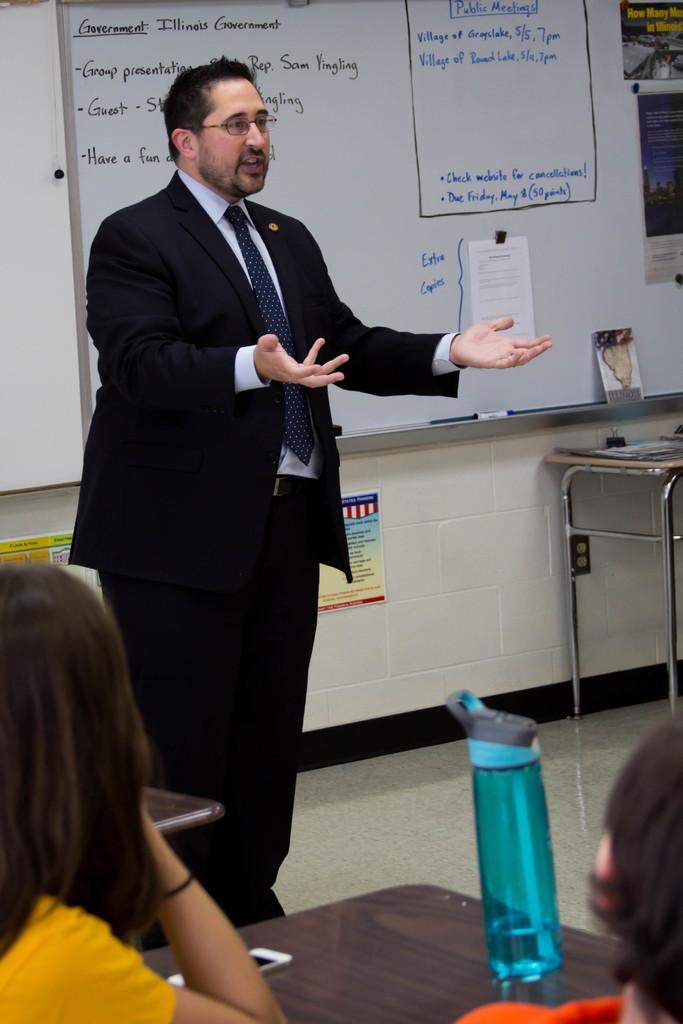Could you give a brief overview of what you see in this image? This picture shows a man standing and speaking we see few people seated and we see a water bottle and a mobile on the table and we see a white board back of him 